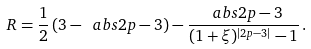<formula> <loc_0><loc_0><loc_500><loc_500>R = \frac { 1 } { 2 } \left ( 3 - \ a b s { 2 p - 3 } \right ) - \frac { \ a b s { 2 p - 3 } } { ( 1 + \xi ) ^ { | 2 p - 3 | } - 1 } \, .</formula> 